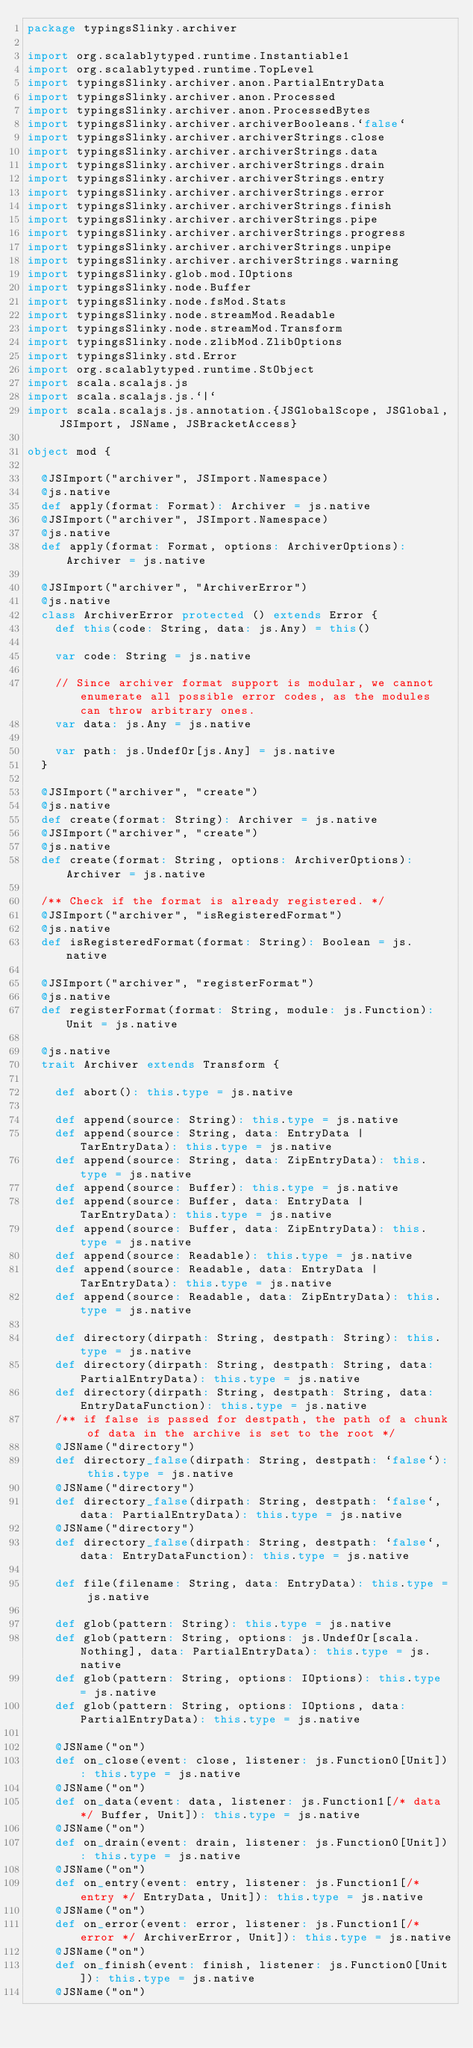Convert code to text. <code><loc_0><loc_0><loc_500><loc_500><_Scala_>package typingsSlinky.archiver

import org.scalablytyped.runtime.Instantiable1
import org.scalablytyped.runtime.TopLevel
import typingsSlinky.archiver.anon.PartialEntryData
import typingsSlinky.archiver.anon.Processed
import typingsSlinky.archiver.anon.ProcessedBytes
import typingsSlinky.archiver.archiverBooleans.`false`
import typingsSlinky.archiver.archiverStrings.close
import typingsSlinky.archiver.archiverStrings.data
import typingsSlinky.archiver.archiverStrings.drain
import typingsSlinky.archiver.archiverStrings.entry
import typingsSlinky.archiver.archiverStrings.error
import typingsSlinky.archiver.archiverStrings.finish
import typingsSlinky.archiver.archiverStrings.pipe
import typingsSlinky.archiver.archiverStrings.progress
import typingsSlinky.archiver.archiverStrings.unpipe
import typingsSlinky.archiver.archiverStrings.warning
import typingsSlinky.glob.mod.IOptions
import typingsSlinky.node.Buffer
import typingsSlinky.node.fsMod.Stats
import typingsSlinky.node.streamMod.Readable
import typingsSlinky.node.streamMod.Transform
import typingsSlinky.node.zlibMod.ZlibOptions
import typingsSlinky.std.Error
import org.scalablytyped.runtime.StObject
import scala.scalajs.js
import scala.scalajs.js.`|`
import scala.scalajs.js.annotation.{JSGlobalScope, JSGlobal, JSImport, JSName, JSBracketAccess}

object mod {
  
  @JSImport("archiver", JSImport.Namespace)
  @js.native
  def apply(format: Format): Archiver = js.native
  @JSImport("archiver", JSImport.Namespace)
  @js.native
  def apply(format: Format, options: ArchiverOptions): Archiver = js.native
  
  @JSImport("archiver", "ArchiverError")
  @js.native
  class ArchiverError protected () extends Error {
    def this(code: String, data: js.Any) = this()
    
    var code: String = js.native
    
    // Since archiver format support is modular, we cannot enumerate all possible error codes, as the modules can throw arbitrary ones.
    var data: js.Any = js.native
    
    var path: js.UndefOr[js.Any] = js.native
  }
  
  @JSImport("archiver", "create")
  @js.native
  def create(format: String): Archiver = js.native
  @JSImport("archiver", "create")
  @js.native
  def create(format: String, options: ArchiverOptions): Archiver = js.native
  
  /** Check if the format is already registered. */
  @JSImport("archiver", "isRegisteredFormat")
  @js.native
  def isRegisteredFormat(format: String): Boolean = js.native
  
  @JSImport("archiver", "registerFormat")
  @js.native
  def registerFormat(format: String, module: js.Function): Unit = js.native
  
  @js.native
  trait Archiver extends Transform {
    
    def abort(): this.type = js.native
    
    def append(source: String): this.type = js.native
    def append(source: String, data: EntryData | TarEntryData): this.type = js.native
    def append(source: String, data: ZipEntryData): this.type = js.native
    def append(source: Buffer): this.type = js.native
    def append(source: Buffer, data: EntryData | TarEntryData): this.type = js.native
    def append(source: Buffer, data: ZipEntryData): this.type = js.native
    def append(source: Readable): this.type = js.native
    def append(source: Readable, data: EntryData | TarEntryData): this.type = js.native
    def append(source: Readable, data: ZipEntryData): this.type = js.native
    
    def directory(dirpath: String, destpath: String): this.type = js.native
    def directory(dirpath: String, destpath: String, data: PartialEntryData): this.type = js.native
    def directory(dirpath: String, destpath: String, data: EntryDataFunction): this.type = js.native
    /** if false is passed for destpath, the path of a chunk of data in the archive is set to the root */
    @JSName("directory")
    def directory_false(dirpath: String, destpath: `false`): this.type = js.native
    @JSName("directory")
    def directory_false(dirpath: String, destpath: `false`, data: PartialEntryData): this.type = js.native
    @JSName("directory")
    def directory_false(dirpath: String, destpath: `false`, data: EntryDataFunction): this.type = js.native
    
    def file(filename: String, data: EntryData): this.type = js.native
    
    def glob(pattern: String): this.type = js.native
    def glob(pattern: String, options: js.UndefOr[scala.Nothing], data: PartialEntryData): this.type = js.native
    def glob(pattern: String, options: IOptions): this.type = js.native
    def glob(pattern: String, options: IOptions, data: PartialEntryData): this.type = js.native
    
    @JSName("on")
    def on_close(event: close, listener: js.Function0[Unit]): this.type = js.native
    @JSName("on")
    def on_data(event: data, listener: js.Function1[/* data */ Buffer, Unit]): this.type = js.native
    @JSName("on")
    def on_drain(event: drain, listener: js.Function0[Unit]): this.type = js.native
    @JSName("on")
    def on_entry(event: entry, listener: js.Function1[/* entry */ EntryData, Unit]): this.type = js.native
    @JSName("on")
    def on_error(event: error, listener: js.Function1[/* error */ ArchiverError, Unit]): this.type = js.native
    @JSName("on")
    def on_finish(event: finish, listener: js.Function0[Unit]): this.type = js.native
    @JSName("on")</code> 